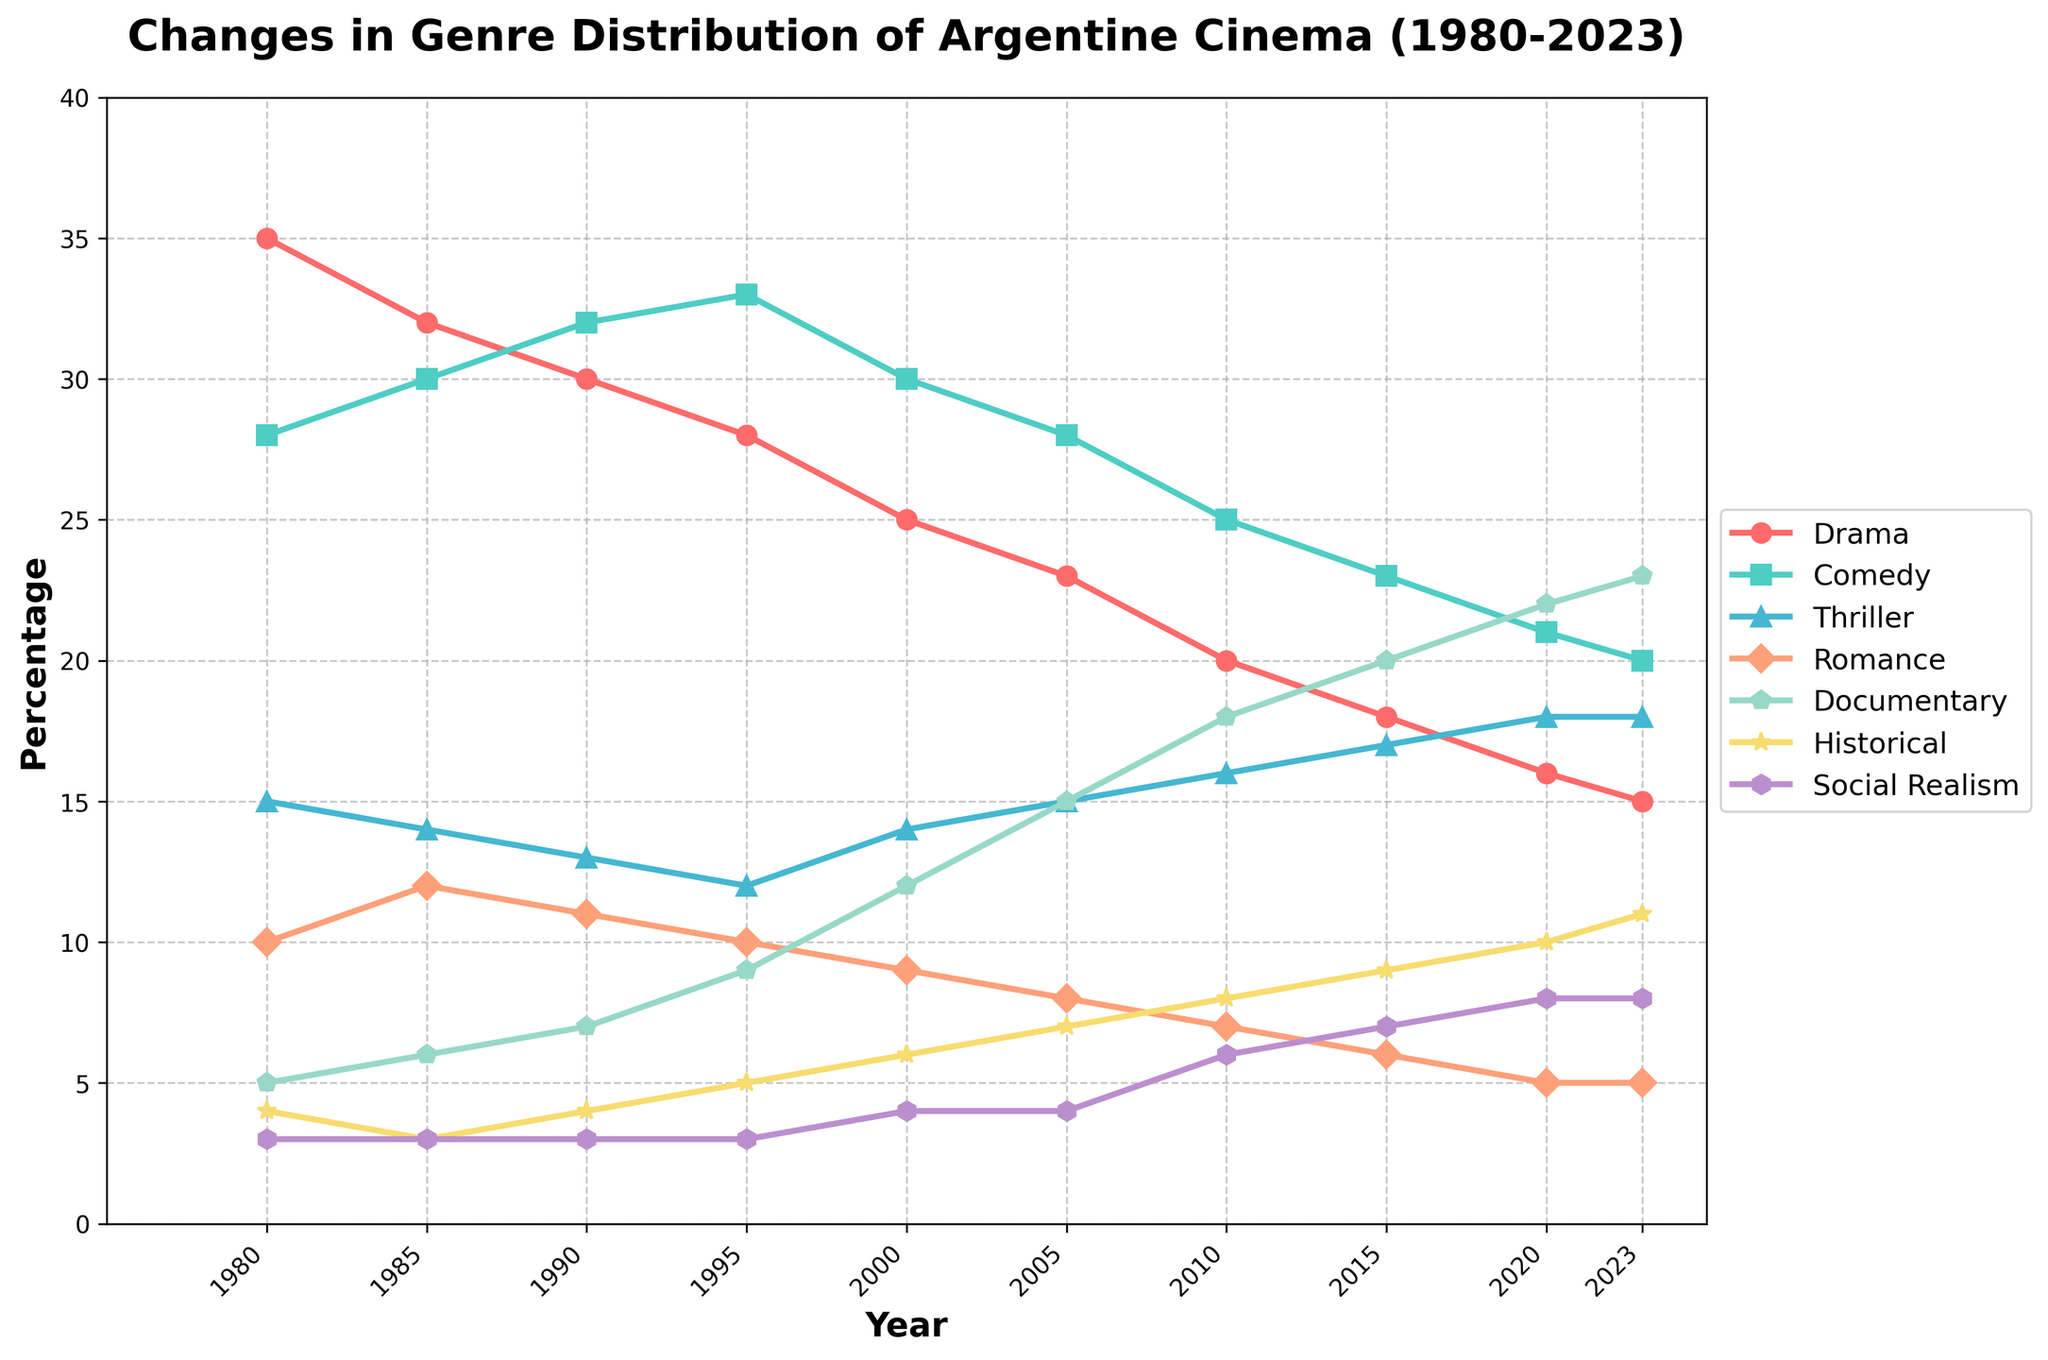What genre had the highest percentage in 1980 and how much was it? By looking at the year 1980 on the x-axis and identifying the highest point for that year, we see that the Drama genre had the highest percentage. The y-axis shows it at the 35 mark.
Answer: Drama with 35% Which genre showed the most consistent increase from 1980 to 2023? Tracking the slopes of the lines from 1980 to 2023, we observe that the Documentary genre shows a steady increase throughout the years, from 5% to 23%.
Answer: Documentary What is the difference in percentage of the Drama genre from 1980 to 2023? The Drama genre starts at 35% in 1980 and decreases to 15% in 2023. Calculating the difference: 35 - 15 = 20.
Answer: 20% What two genres had equal percentages at any year, and when did that occur? By identifying overlappings in the lines, the Thriller and Romance genres both show the same percentage values of 18% in 2020.
Answer: Thriller and Romance in 2020 Which genre experienced a decrease from 2000 to 2023? Checking the trends between 2000 and 2023, the Drama genre shows a clear decrease from 25% to 15%.
Answer: Drama What's the sum of the percentages of Documentary and Historical genres in 2023? In 2023, Documentary is at 23% and Historical is at 11%. Summing these gives: 23 + 11 = 34.
Answer: 34% Is there any year where Comedy was the most produced genre? By tracing the Comedy line, we notice that in 1995, Comedy hit 33% whereas all other genres were below this percentage.
Answer: Yes, in 1995 What’s the average percentage of Social Realism over the years? Adding the Social Realism percentages over all years: 3 + 3 + 3 + 3 + 4 + 4 + 6 + 7 + 8 + 8 = 49. Dividing by 10 years: 49 / 10 = 4.9.
Answer: 4.9% Which genre had the least fluctuation in its percentage over the years? Comparing the lines for each genre, the Social Realism genre tends to remain quite steady with minimal changes, ranging from 3% to 8%.
Answer: Social Realism 